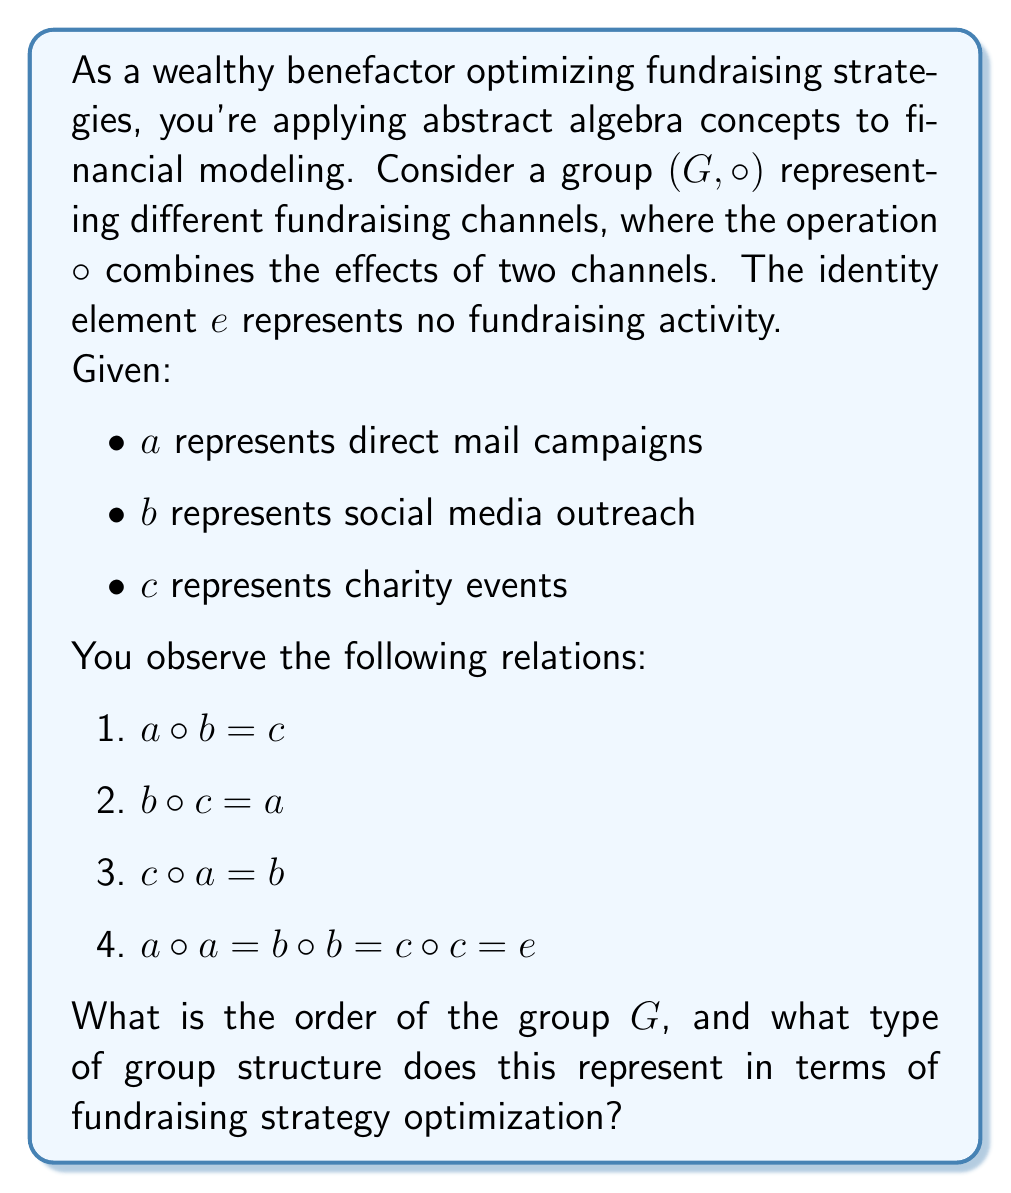What is the answer to this math problem? Let's approach this step-by-step:

1) First, let's identify the elements of the group $G$. From the given information, we can see that $G = \{e, a, b, c\}$.

2) Now, let's verify if this is indeed a group:
   - Closure: The operation table is complete with all combinations resulting in elements within the set.
   - Associativity: This is assumed for the given operation $\circ$.
   - Identity: We're given that $e$ is the identity element.
   - Inverse: We can see that each element is its own inverse (e.g., $a \circ a = e$).

3) The order of a group is the number of elements in the group. Here, $|G| = 4$.

4) To identify the type of group, let's look at its properties:
   - It has 4 elements.
   - Each non-identity element has order 2 (i.e., $a \circ a = b \circ b = c \circ c = e$).
   - The operation is commutative (can be verified from the given relations).

5) These properties uniquely identify this group as isomorphic to the Klein four-group, also known as $V_4$ or $\mathbb{Z}_2 \times \mathbb{Z}_2$.

6) In terms of fundraising strategy optimization, this group structure suggests:
   - Each fundraising channel (a, b, c) is equally effective on its own.
   - Combining any two different channels always results in the third channel.
   - Using the same channel twice is equivalent to not fundraising at all (possibly due to donor fatigue).
   - The order in which channels are combined doesn't matter (commutativity).

This structure allows for balanced and flexible fundraising strategies, where different combinations of channels can be used interchangeably to achieve desired outcomes.
Answer: Order: 4; Type: Klein four-group ($V_4$) 